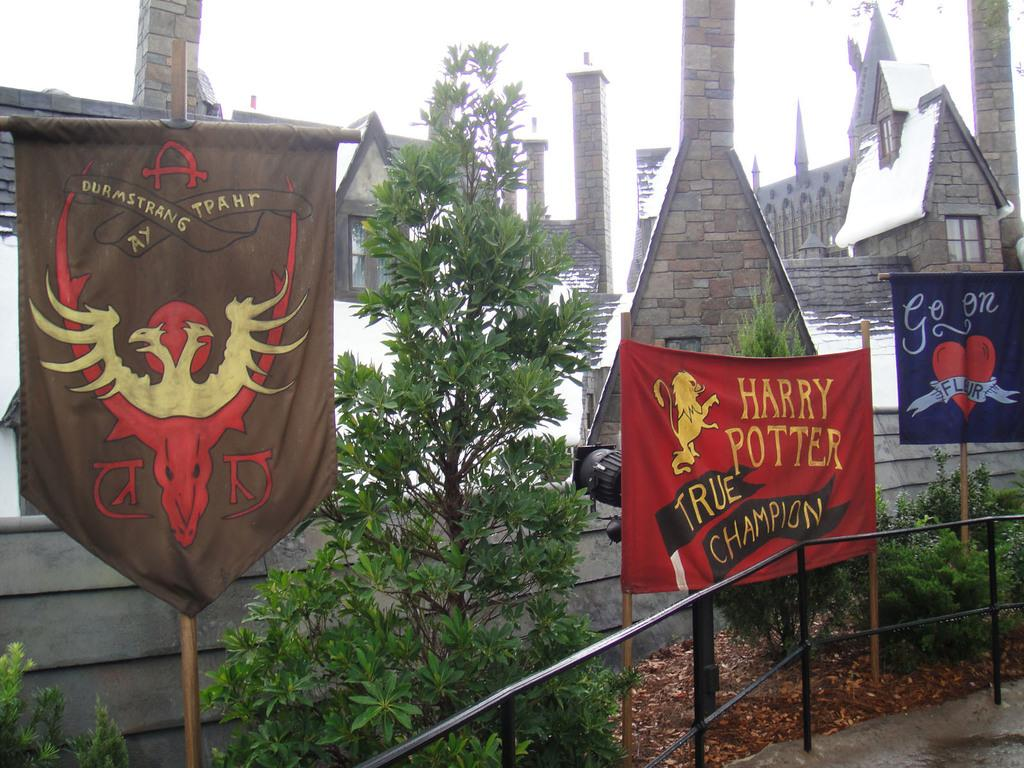<image>
Summarize the visual content of the image. Harry Potter true champion banner and Durmstrang Ay Tpahr banner. 